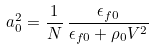Convert formula to latex. <formula><loc_0><loc_0><loc_500><loc_500>a _ { 0 } ^ { 2 } = \frac { 1 } { N } \, \frac { \epsilon _ { f 0 } } { \epsilon _ { f 0 } + \rho _ { 0 } V ^ { 2 } } \,</formula> 